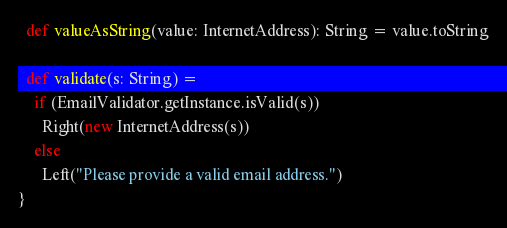Convert code to text. <code><loc_0><loc_0><loc_500><loc_500><_Scala_>
  def valueAsString(value: InternetAddress): String = value.toString

  def validate(s: String) =
    if (EmailValidator.getInstance.isValid(s))
      Right(new InternetAddress(s))
    else
      Left("Please provide a valid email address.")
}
</code> 